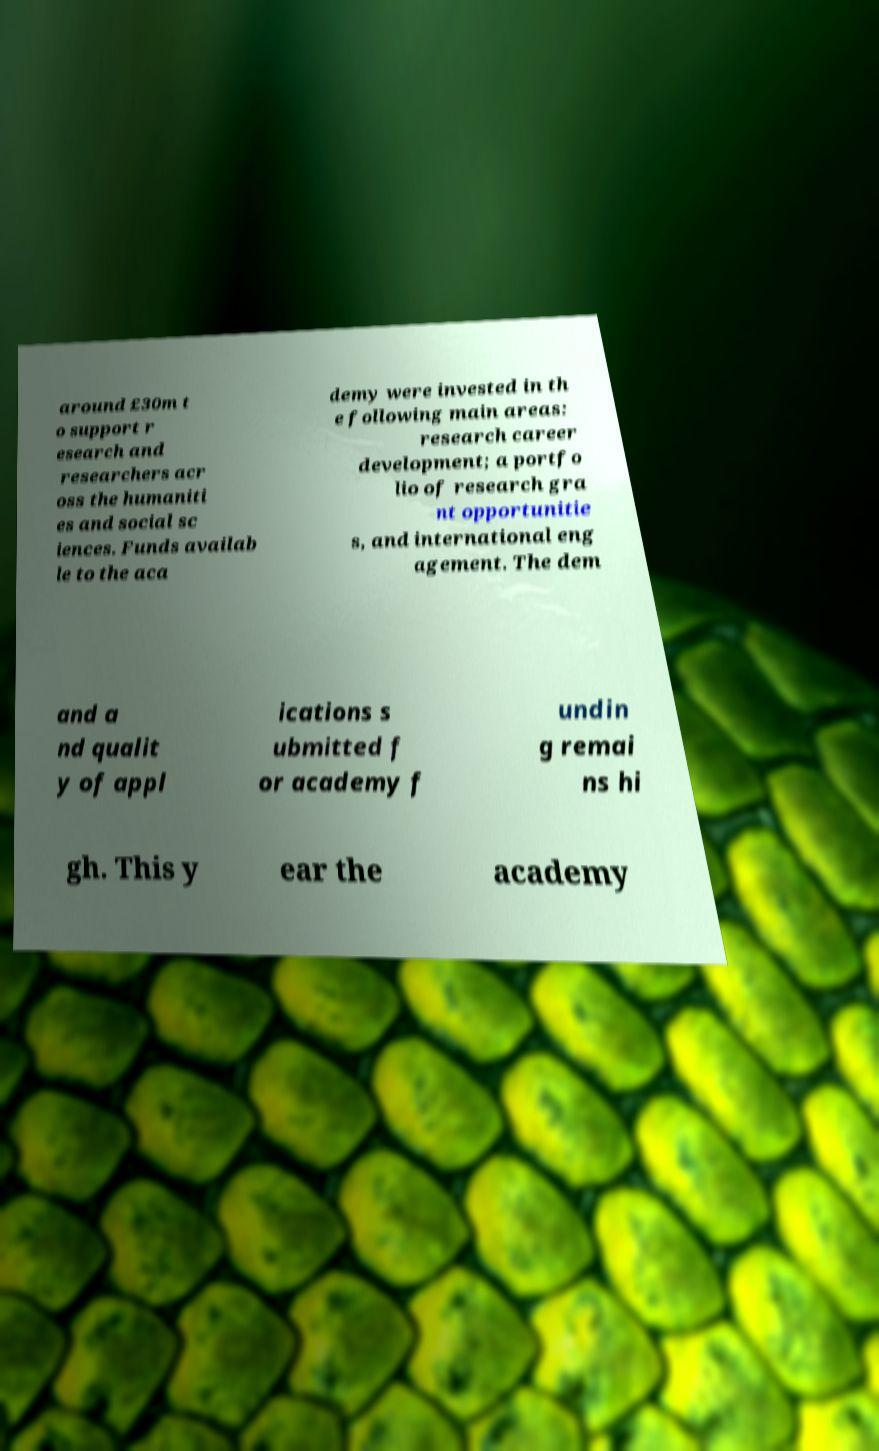Could you assist in decoding the text presented in this image and type it out clearly? around £30m t o support r esearch and researchers acr oss the humaniti es and social sc iences. Funds availab le to the aca demy were invested in th e following main areas: research career development; a portfo lio of research gra nt opportunitie s, and international eng agement. The dem and a nd qualit y of appl ications s ubmitted f or academy f undin g remai ns hi gh. This y ear the academy 